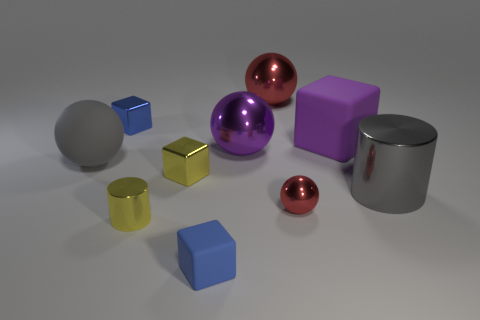Subtract all purple spheres. How many spheres are left? 3 Subtract all green cylinders. How many blue blocks are left? 2 Subtract 2 cubes. How many cubes are left? 2 Subtract all purple spheres. How many spheres are left? 3 Subtract all spheres. How many objects are left? 6 Subtract all brown cubes. Subtract all cyan spheres. How many cubes are left? 4 Add 5 big purple rubber objects. How many big purple rubber objects exist? 6 Subtract 1 yellow cubes. How many objects are left? 9 Subtract all metallic cubes. Subtract all tiny blue metal objects. How many objects are left? 7 Add 3 large metal balls. How many large metal balls are left? 5 